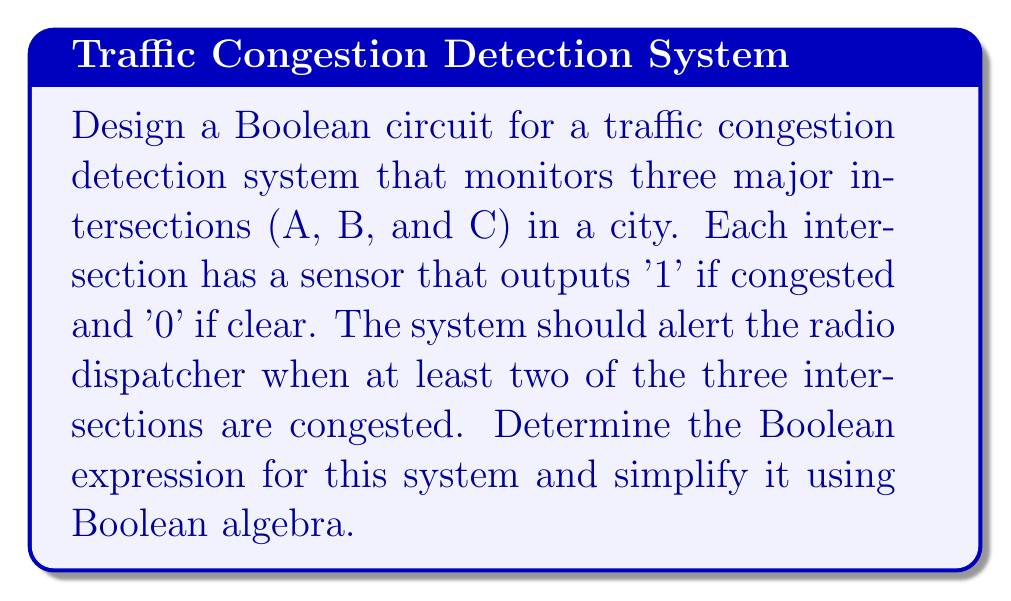Teach me how to tackle this problem. Let's approach this step-by-step:

1) Define variables:
   A = 1 if intersection A is congested, 0 otherwise
   B = 1 if intersection B is congested, 0 otherwise
   C = 1 if intersection C is congested, 0 otherwise

2) The system should alert when at least two intersections are congested. This can be expressed as:

   $$(A \cdot B) + (A \cdot C) + (B \cdot C)$$

3) This expression can be simplified using Boolean algebra:

   $$(A \cdot B) + (A \cdot C) + (B \cdot C)$$
   $$= A \cdot (B + C) + (B \cdot C)$$ (Distributive law)
   $$= A \cdot (B + C) + B \cdot C$$ (Parentheses not needed for AND)

4) This simplified expression represents our final Boolean circuit. It consists of:
   - Two AND gates (A·(B+C) and B·C)
   - One OR gate (B+C)
   - One final OR gate to combine the results of the two AND gates

5) In terms of implementation, this circuit would take inputs from the three intersection sensors and output a '1' (alert) when the expression is true, i.e., when at least two intersections are congested.
Answer: $$A \cdot (B + C) + B \cdot C$$ 